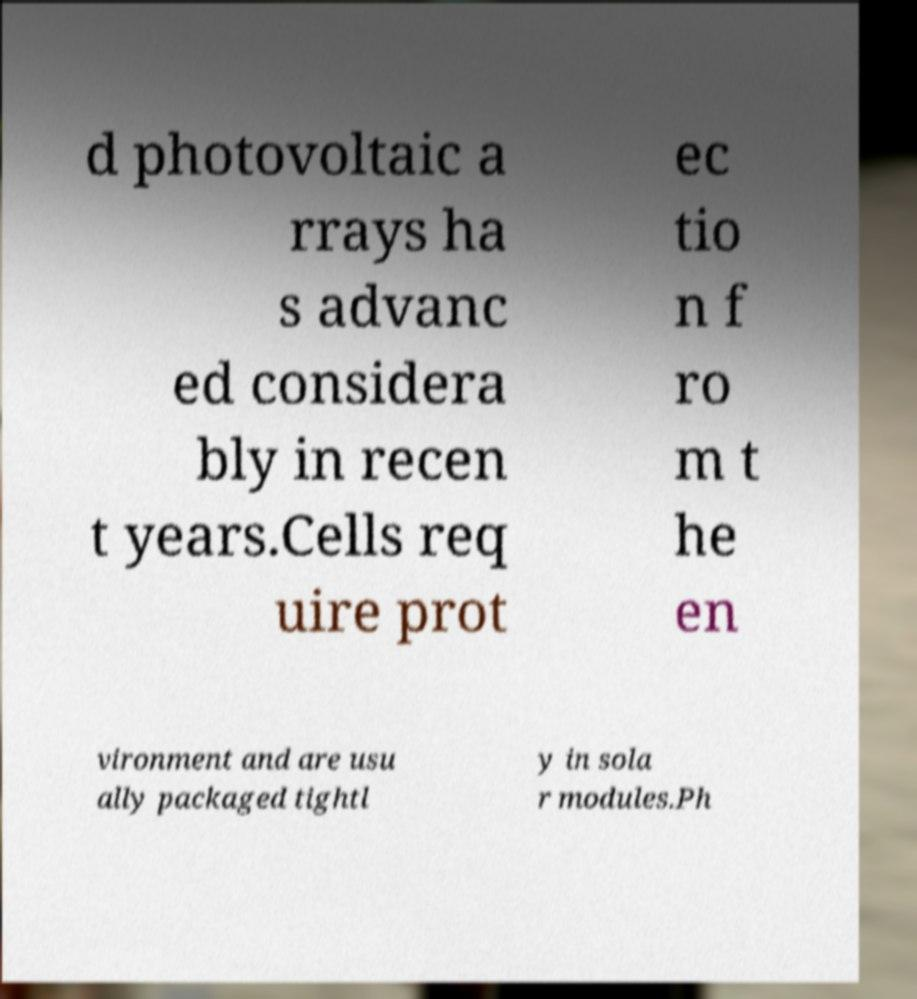Please identify and transcribe the text found in this image. d photovoltaic a rrays ha s advanc ed considera bly in recen t years.Cells req uire prot ec tio n f ro m t he en vironment and are usu ally packaged tightl y in sola r modules.Ph 